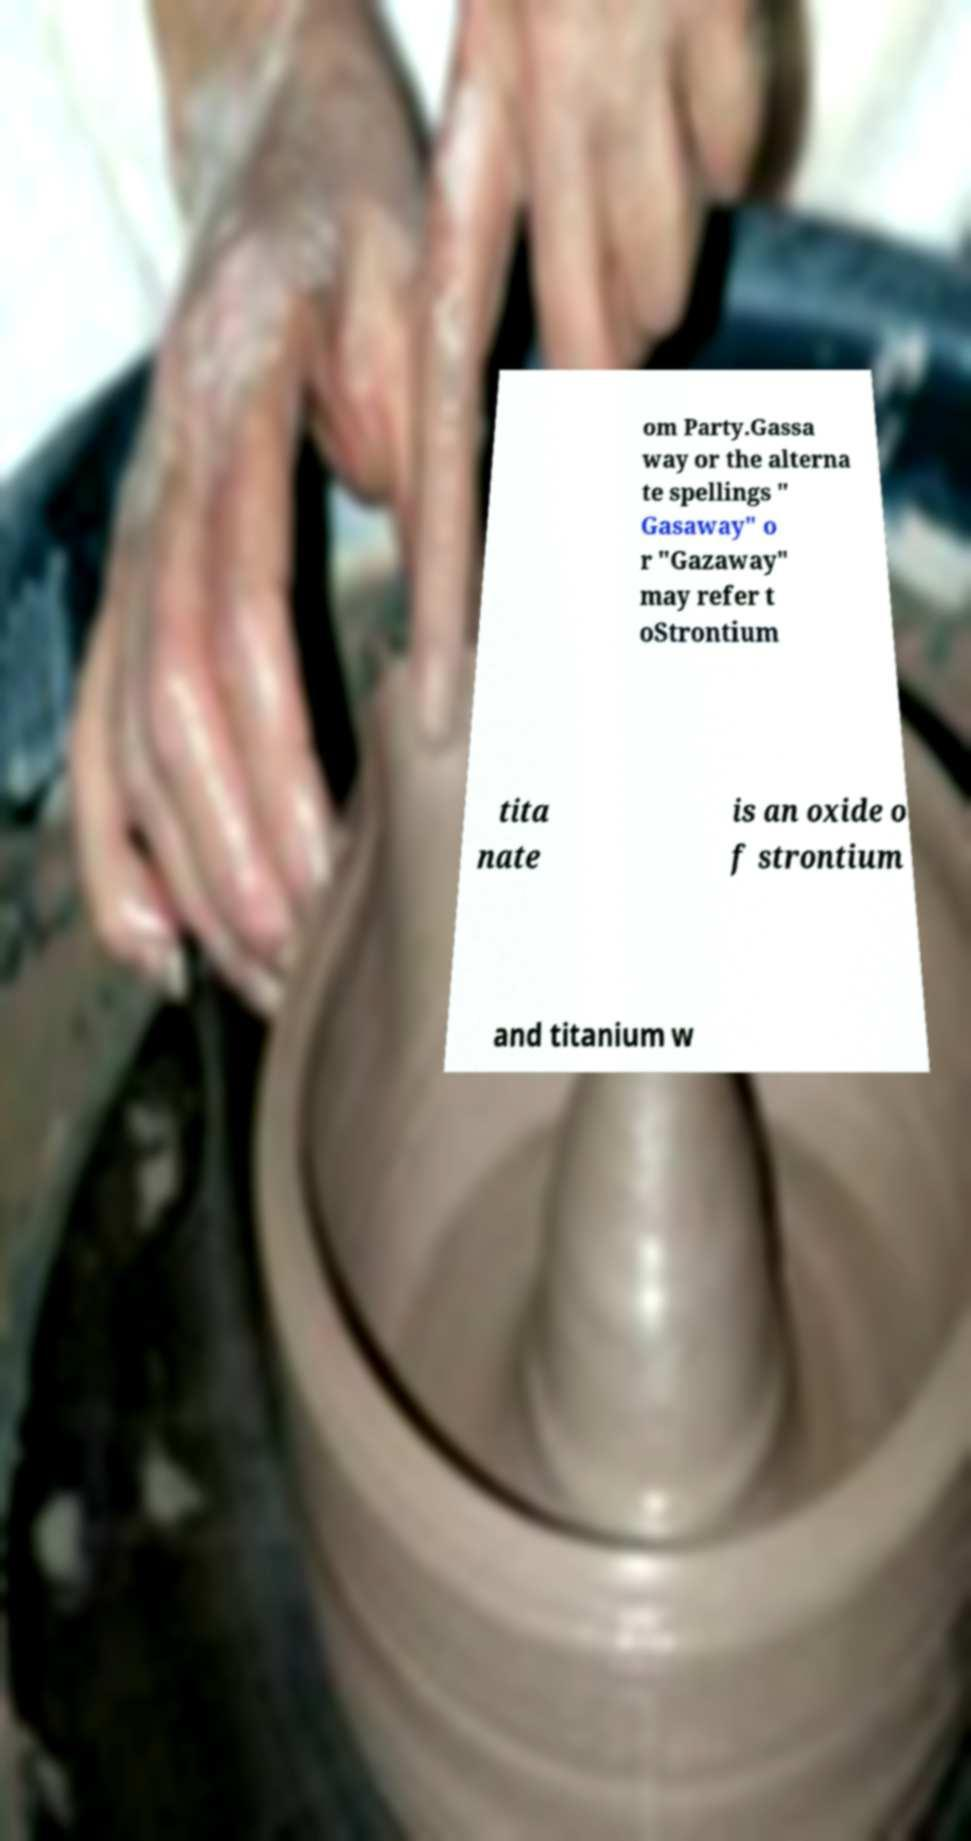Please read and relay the text visible in this image. What does it say? om Party.Gassa way or the alterna te spellings " Gasaway" o r "Gazaway" may refer t oStrontium tita nate is an oxide o f strontium and titanium w 